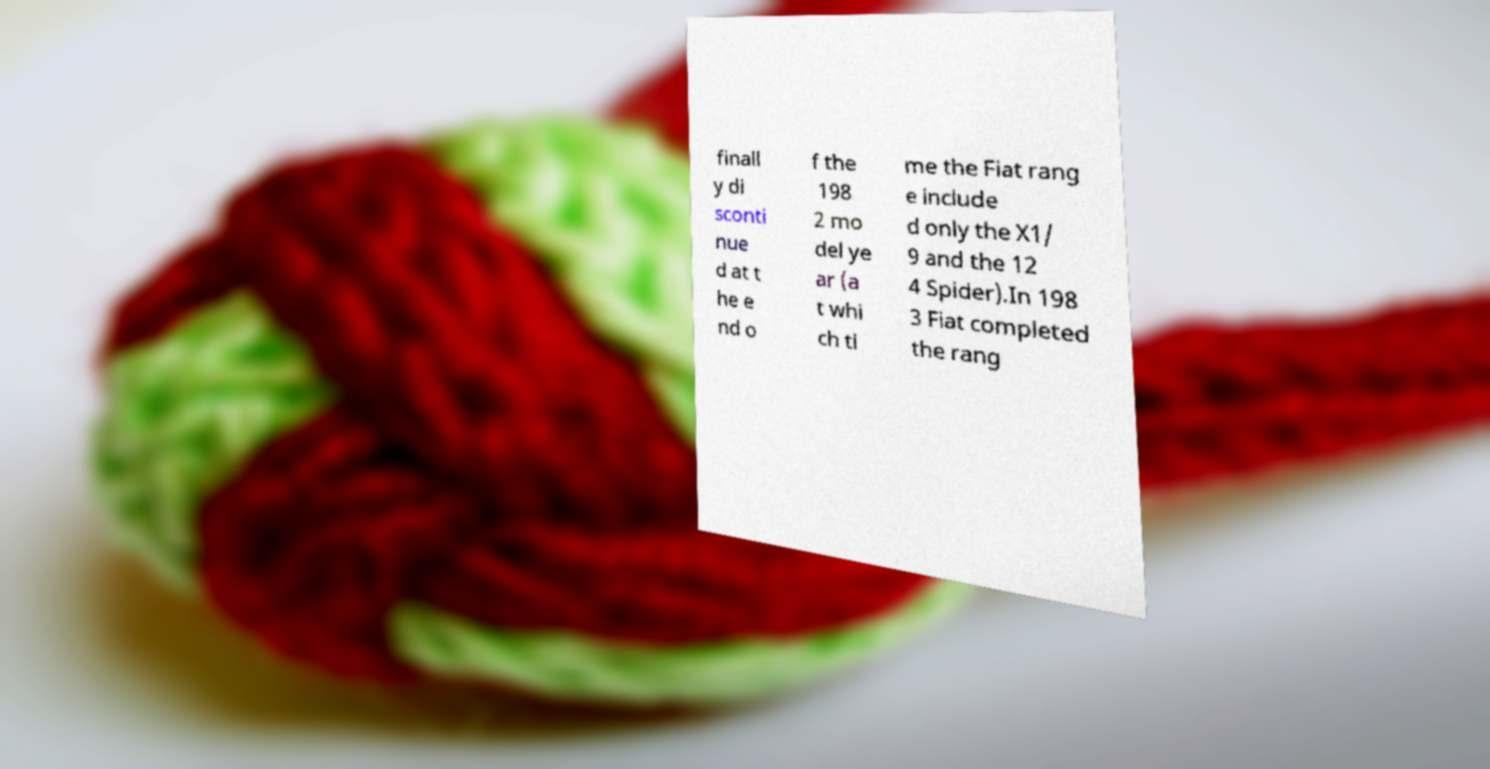Can you accurately transcribe the text from the provided image for me? finall y di sconti nue d at t he e nd o f the 198 2 mo del ye ar (a t whi ch ti me the Fiat rang e include d only the X1/ 9 and the 12 4 Spider).In 198 3 Fiat completed the rang 